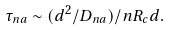<formula> <loc_0><loc_0><loc_500><loc_500>\tau _ { n a } \sim ( d ^ { 2 } / D _ { n a } ) / n R _ { c } d .</formula> 